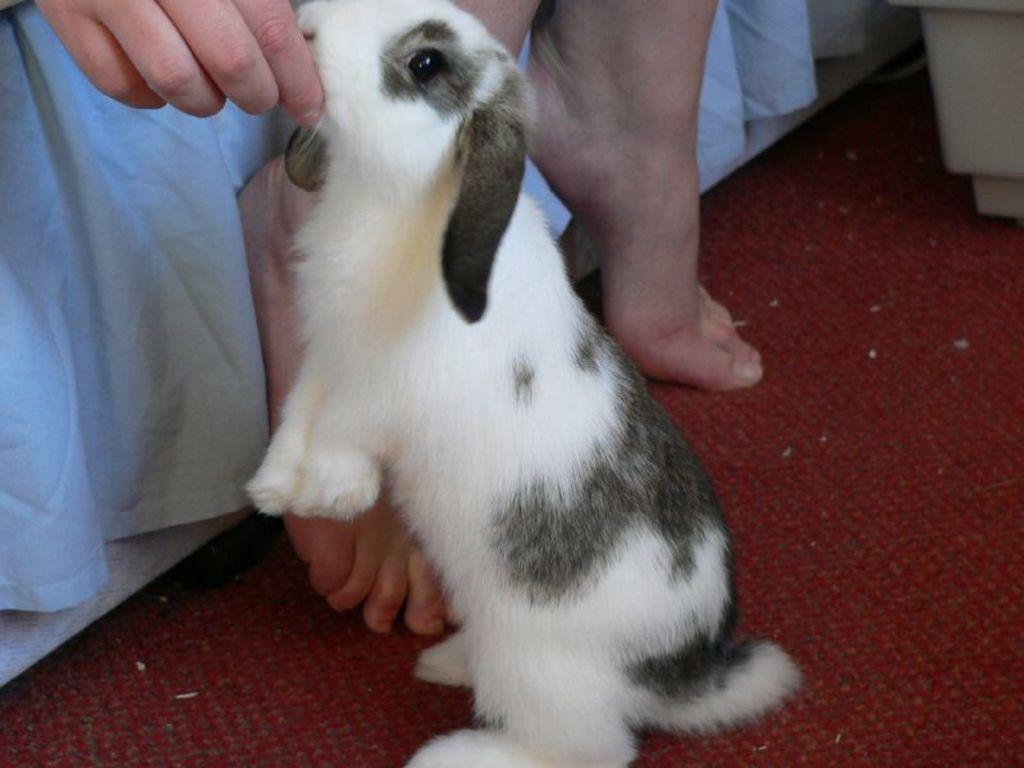Could you give a brief overview of what you see in this image? In this image we can see a person holding a rabbit with his hand. 